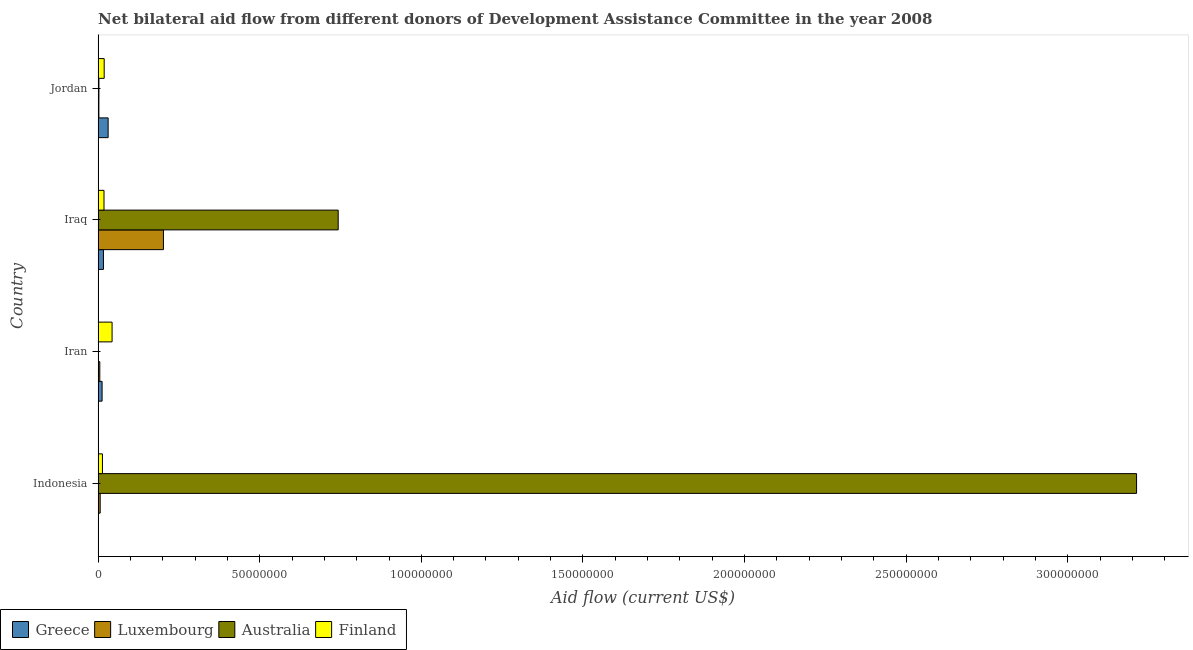Are the number of bars per tick equal to the number of legend labels?
Provide a succinct answer. Yes. Are the number of bars on each tick of the Y-axis equal?
Your answer should be compact. Yes. How many bars are there on the 4th tick from the bottom?
Your response must be concise. 4. What is the label of the 2nd group of bars from the top?
Provide a short and direct response. Iraq. In how many cases, is the number of bars for a given country not equal to the number of legend labels?
Your answer should be very brief. 0. What is the amount of aid given by luxembourg in Iran?
Ensure brevity in your answer.  5.20e+05. Across all countries, what is the maximum amount of aid given by greece?
Give a very brief answer. 3.10e+06. Across all countries, what is the minimum amount of aid given by luxembourg?
Your response must be concise. 2.40e+05. In which country was the amount of aid given by finland maximum?
Offer a very short reply. Iran. In which country was the amount of aid given by finland minimum?
Your response must be concise. Indonesia. What is the total amount of aid given by finland in the graph?
Offer a terse response. 9.36e+06. What is the difference between the amount of aid given by finland in Indonesia and that in Iran?
Provide a short and direct response. -2.98e+06. What is the difference between the amount of aid given by australia in Indonesia and the amount of aid given by luxembourg in Iraq?
Your answer should be compact. 3.01e+08. What is the average amount of aid given by luxembourg per country?
Your answer should be compact. 5.40e+06. What is the difference between the amount of aid given by australia and amount of aid given by greece in Jordan?
Your response must be concise. -2.85e+06. What is the ratio of the amount of aid given by australia in Iran to that in Jordan?
Your response must be concise. 0.12. Is the difference between the amount of aid given by luxembourg in Iraq and Jordan greater than the difference between the amount of aid given by greece in Iraq and Jordan?
Your answer should be very brief. Yes. What is the difference between the highest and the second highest amount of aid given by australia?
Provide a succinct answer. 2.47e+08. What is the difference between the highest and the lowest amount of aid given by australia?
Offer a terse response. 3.21e+08. In how many countries, is the amount of aid given by greece greater than the average amount of aid given by greece taken over all countries?
Ensure brevity in your answer.  2. What does the 3rd bar from the top in Indonesia represents?
Make the answer very short. Luxembourg. What does the 2nd bar from the bottom in Indonesia represents?
Keep it short and to the point. Luxembourg. How many bars are there?
Make the answer very short. 16. Are all the bars in the graph horizontal?
Provide a short and direct response. Yes. What is the difference between two consecutive major ticks on the X-axis?
Provide a short and direct response. 5.00e+07. Does the graph contain any zero values?
Make the answer very short. No. Does the graph contain grids?
Your response must be concise. No. How are the legend labels stacked?
Provide a short and direct response. Horizontal. What is the title of the graph?
Ensure brevity in your answer.  Net bilateral aid flow from different donors of Development Assistance Committee in the year 2008. Does "United Kingdom" appear as one of the legend labels in the graph?
Ensure brevity in your answer.  No. What is the label or title of the X-axis?
Keep it short and to the point. Aid flow (current US$). What is the label or title of the Y-axis?
Make the answer very short. Country. What is the Aid flow (current US$) in Greece in Indonesia?
Offer a terse response. 5.00e+04. What is the Aid flow (current US$) of Luxembourg in Indonesia?
Give a very brief answer. 6.40e+05. What is the Aid flow (current US$) of Australia in Indonesia?
Offer a very short reply. 3.21e+08. What is the Aid flow (current US$) in Finland in Indonesia?
Provide a succinct answer. 1.34e+06. What is the Aid flow (current US$) of Greece in Iran?
Your answer should be compact. 1.23e+06. What is the Aid flow (current US$) in Luxembourg in Iran?
Offer a very short reply. 5.20e+05. What is the Aid flow (current US$) of Finland in Iran?
Offer a terse response. 4.32e+06. What is the Aid flow (current US$) of Greece in Iraq?
Make the answer very short. 1.65e+06. What is the Aid flow (current US$) of Luxembourg in Iraq?
Provide a succinct answer. 2.02e+07. What is the Aid flow (current US$) of Australia in Iraq?
Give a very brief answer. 7.43e+07. What is the Aid flow (current US$) of Finland in Iraq?
Give a very brief answer. 1.82e+06. What is the Aid flow (current US$) of Greece in Jordan?
Offer a very short reply. 3.10e+06. What is the Aid flow (current US$) in Luxembourg in Jordan?
Your answer should be compact. 2.40e+05. What is the Aid flow (current US$) of Australia in Jordan?
Your answer should be very brief. 2.50e+05. What is the Aid flow (current US$) in Finland in Jordan?
Make the answer very short. 1.88e+06. Across all countries, what is the maximum Aid flow (current US$) in Greece?
Make the answer very short. 3.10e+06. Across all countries, what is the maximum Aid flow (current US$) in Luxembourg?
Provide a succinct answer. 2.02e+07. Across all countries, what is the maximum Aid flow (current US$) in Australia?
Offer a very short reply. 3.21e+08. Across all countries, what is the maximum Aid flow (current US$) in Finland?
Ensure brevity in your answer.  4.32e+06. Across all countries, what is the minimum Aid flow (current US$) in Greece?
Make the answer very short. 5.00e+04. Across all countries, what is the minimum Aid flow (current US$) of Finland?
Offer a very short reply. 1.34e+06. What is the total Aid flow (current US$) in Greece in the graph?
Give a very brief answer. 6.03e+06. What is the total Aid flow (current US$) of Luxembourg in the graph?
Your answer should be very brief. 2.16e+07. What is the total Aid flow (current US$) of Australia in the graph?
Your response must be concise. 3.96e+08. What is the total Aid flow (current US$) of Finland in the graph?
Offer a very short reply. 9.36e+06. What is the difference between the Aid flow (current US$) of Greece in Indonesia and that in Iran?
Your answer should be compact. -1.18e+06. What is the difference between the Aid flow (current US$) in Luxembourg in Indonesia and that in Iran?
Keep it short and to the point. 1.20e+05. What is the difference between the Aid flow (current US$) of Australia in Indonesia and that in Iran?
Your answer should be compact. 3.21e+08. What is the difference between the Aid flow (current US$) in Finland in Indonesia and that in Iran?
Your response must be concise. -2.98e+06. What is the difference between the Aid flow (current US$) in Greece in Indonesia and that in Iraq?
Offer a very short reply. -1.60e+06. What is the difference between the Aid flow (current US$) of Luxembourg in Indonesia and that in Iraq?
Your answer should be very brief. -1.96e+07. What is the difference between the Aid flow (current US$) in Australia in Indonesia and that in Iraq?
Offer a very short reply. 2.47e+08. What is the difference between the Aid flow (current US$) of Finland in Indonesia and that in Iraq?
Keep it short and to the point. -4.80e+05. What is the difference between the Aid flow (current US$) of Greece in Indonesia and that in Jordan?
Your answer should be compact. -3.05e+06. What is the difference between the Aid flow (current US$) in Luxembourg in Indonesia and that in Jordan?
Ensure brevity in your answer.  4.00e+05. What is the difference between the Aid flow (current US$) of Australia in Indonesia and that in Jordan?
Offer a terse response. 3.21e+08. What is the difference between the Aid flow (current US$) of Finland in Indonesia and that in Jordan?
Make the answer very short. -5.40e+05. What is the difference between the Aid flow (current US$) of Greece in Iran and that in Iraq?
Ensure brevity in your answer.  -4.20e+05. What is the difference between the Aid flow (current US$) in Luxembourg in Iran and that in Iraq?
Your response must be concise. -1.97e+07. What is the difference between the Aid flow (current US$) in Australia in Iran and that in Iraq?
Ensure brevity in your answer.  -7.42e+07. What is the difference between the Aid flow (current US$) of Finland in Iran and that in Iraq?
Make the answer very short. 2.50e+06. What is the difference between the Aid flow (current US$) of Greece in Iran and that in Jordan?
Give a very brief answer. -1.87e+06. What is the difference between the Aid flow (current US$) in Luxembourg in Iran and that in Jordan?
Offer a very short reply. 2.80e+05. What is the difference between the Aid flow (current US$) of Australia in Iran and that in Jordan?
Ensure brevity in your answer.  -2.20e+05. What is the difference between the Aid flow (current US$) in Finland in Iran and that in Jordan?
Ensure brevity in your answer.  2.44e+06. What is the difference between the Aid flow (current US$) in Greece in Iraq and that in Jordan?
Your answer should be very brief. -1.45e+06. What is the difference between the Aid flow (current US$) in Luxembourg in Iraq and that in Jordan?
Offer a terse response. 2.00e+07. What is the difference between the Aid flow (current US$) in Australia in Iraq and that in Jordan?
Make the answer very short. 7.40e+07. What is the difference between the Aid flow (current US$) in Greece in Indonesia and the Aid flow (current US$) in Luxembourg in Iran?
Keep it short and to the point. -4.70e+05. What is the difference between the Aid flow (current US$) in Greece in Indonesia and the Aid flow (current US$) in Finland in Iran?
Provide a short and direct response. -4.27e+06. What is the difference between the Aid flow (current US$) in Luxembourg in Indonesia and the Aid flow (current US$) in Australia in Iran?
Your response must be concise. 6.10e+05. What is the difference between the Aid flow (current US$) of Luxembourg in Indonesia and the Aid flow (current US$) of Finland in Iran?
Offer a very short reply. -3.68e+06. What is the difference between the Aid flow (current US$) in Australia in Indonesia and the Aid flow (current US$) in Finland in Iran?
Provide a succinct answer. 3.17e+08. What is the difference between the Aid flow (current US$) in Greece in Indonesia and the Aid flow (current US$) in Luxembourg in Iraq?
Make the answer very short. -2.02e+07. What is the difference between the Aid flow (current US$) of Greece in Indonesia and the Aid flow (current US$) of Australia in Iraq?
Ensure brevity in your answer.  -7.42e+07. What is the difference between the Aid flow (current US$) in Greece in Indonesia and the Aid flow (current US$) in Finland in Iraq?
Make the answer very short. -1.77e+06. What is the difference between the Aid flow (current US$) of Luxembourg in Indonesia and the Aid flow (current US$) of Australia in Iraq?
Provide a short and direct response. -7.36e+07. What is the difference between the Aid flow (current US$) in Luxembourg in Indonesia and the Aid flow (current US$) in Finland in Iraq?
Your answer should be compact. -1.18e+06. What is the difference between the Aid flow (current US$) of Australia in Indonesia and the Aid flow (current US$) of Finland in Iraq?
Ensure brevity in your answer.  3.19e+08. What is the difference between the Aid flow (current US$) of Greece in Indonesia and the Aid flow (current US$) of Luxembourg in Jordan?
Make the answer very short. -1.90e+05. What is the difference between the Aid flow (current US$) of Greece in Indonesia and the Aid flow (current US$) of Australia in Jordan?
Your response must be concise. -2.00e+05. What is the difference between the Aid flow (current US$) of Greece in Indonesia and the Aid flow (current US$) of Finland in Jordan?
Ensure brevity in your answer.  -1.83e+06. What is the difference between the Aid flow (current US$) of Luxembourg in Indonesia and the Aid flow (current US$) of Finland in Jordan?
Offer a terse response. -1.24e+06. What is the difference between the Aid flow (current US$) of Australia in Indonesia and the Aid flow (current US$) of Finland in Jordan?
Offer a terse response. 3.19e+08. What is the difference between the Aid flow (current US$) in Greece in Iran and the Aid flow (current US$) in Luxembourg in Iraq?
Give a very brief answer. -1.90e+07. What is the difference between the Aid flow (current US$) of Greece in Iran and the Aid flow (current US$) of Australia in Iraq?
Provide a succinct answer. -7.30e+07. What is the difference between the Aid flow (current US$) of Greece in Iran and the Aid flow (current US$) of Finland in Iraq?
Keep it short and to the point. -5.90e+05. What is the difference between the Aid flow (current US$) of Luxembourg in Iran and the Aid flow (current US$) of Australia in Iraq?
Make the answer very short. -7.38e+07. What is the difference between the Aid flow (current US$) of Luxembourg in Iran and the Aid flow (current US$) of Finland in Iraq?
Your answer should be very brief. -1.30e+06. What is the difference between the Aid flow (current US$) of Australia in Iran and the Aid flow (current US$) of Finland in Iraq?
Make the answer very short. -1.79e+06. What is the difference between the Aid flow (current US$) of Greece in Iran and the Aid flow (current US$) of Luxembourg in Jordan?
Offer a terse response. 9.90e+05. What is the difference between the Aid flow (current US$) of Greece in Iran and the Aid flow (current US$) of Australia in Jordan?
Offer a very short reply. 9.80e+05. What is the difference between the Aid flow (current US$) of Greece in Iran and the Aid flow (current US$) of Finland in Jordan?
Give a very brief answer. -6.50e+05. What is the difference between the Aid flow (current US$) of Luxembourg in Iran and the Aid flow (current US$) of Finland in Jordan?
Ensure brevity in your answer.  -1.36e+06. What is the difference between the Aid flow (current US$) of Australia in Iran and the Aid flow (current US$) of Finland in Jordan?
Give a very brief answer. -1.85e+06. What is the difference between the Aid flow (current US$) in Greece in Iraq and the Aid flow (current US$) in Luxembourg in Jordan?
Offer a very short reply. 1.41e+06. What is the difference between the Aid flow (current US$) of Greece in Iraq and the Aid flow (current US$) of Australia in Jordan?
Give a very brief answer. 1.40e+06. What is the difference between the Aid flow (current US$) of Luxembourg in Iraq and the Aid flow (current US$) of Australia in Jordan?
Keep it short and to the point. 2.00e+07. What is the difference between the Aid flow (current US$) in Luxembourg in Iraq and the Aid flow (current US$) in Finland in Jordan?
Make the answer very short. 1.83e+07. What is the difference between the Aid flow (current US$) of Australia in Iraq and the Aid flow (current US$) of Finland in Jordan?
Offer a very short reply. 7.24e+07. What is the average Aid flow (current US$) in Greece per country?
Your response must be concise. 1.51e+06. What is the average Aid flow (current US$) of Luxembourg per country?
Keep it short and to the point. 5.40e+06. What is the average Aid flow (current US$) of Australia per country?
Offer a terse response. 9.90e+07. What is the average Aid flow (current US$) in Finland per country?
Your answer should be very brief. 2.34e+06. What is the difference between the Aid flow (current US$) in Greece and Aid flow (current US$) in Luxembourg in Indonesia?
Offer a terse response. -5.90e+05. What is the difference between the Aid flow (current US$) of Greece and Aid flow (current US$) of Australia in Indonesia?
Your answer should be compact. -3.21e+08. What is the difference between the Aid flow (current US$) of Greece and Aid flow (current US$) of Finland in Indonesia?
Your response must be concise. -1.29e+06. What is the difference between the Aid flow (current US$) of Luxembourg and Aid flow (current US$) of Australia in Indonesia?
Provide a succinct answer. -3.21e+08. What is the difference between the Aid flow (current US$) of Luxembourg and Aid flow (current US$) of Finland in Indonesia?
Provide a succinct answer. -7.00e+05. What is the difference between the Aid flow (current US$) in Australia and Aid flow (current US$) in Finland in Indonesia?
Your response must be concise. 3.20e+08. What is the difference between the Aid flow (current US$) in Greece and Aid flow (current US$) in Luxembourg in Iran?
Give a very brief answer. 7.10e+05. What is the difference between the Aid flow (current US$) in Greece and Aid flow (current US$) in Australia in Iran?
Give a very brief answer. 1.20e+06. What is the difference between the Aid flow (current US$) in Greece and Aid flow (current US$) in Finland in Iran?
Keep it short and to the point. -3.09e+06. What is the difference between the Aid flow (current US$) in Luxembourg and Aid flow (current US$) in Australia in Iran?
Provide a short and direct response. 4.90e+05. What is the difference between the Aid flow (current US$) in Luxembourg and Aid flow (current US$) in Finland in Iran?
Offer a very short reply. -3.80e+06. What is the difference between the Aid flow (current US$) of Australia and Aid flow (current US$) of Finland in Iran?
Offer a very short reply. -4.29e+06. What is the difference between the Aid flow (current US$) of Greece and Aid flow (current US$) of Luxembourg in Iraq?
Make the answer very short. -1.86e+07. What is the difference between the Aid flow (current US$) in Greece and Aid flow (current US$) in Australia in Iraq?
Offer a very short reply. -7.26e+07. What is the difference between the Aid flow (current US$) in Luxembourg and Aid flow (current US$) in Australia in Iraq?
Provide a short and direct response. -5.41e+07. What is the difference between the Aid flow (current US$) of Luxembourg and Aid flow (current US$) of Finland in Iraq?
Your answer should be compact. 1.84e+07. What is the difference between the Aid flow (current US$) of Australia and Aid flow (current US$) of Finland in Iraq?
Provide a succinct answer. 7.25e+07. What is the difference between the Aid flow (current US$) in Greece and Aid flow (current US$) in Luxembourg in Jordan?
Provide a succinct answer. 2.86e+06. What is the difference between the Aid flow (current US$) of Greece and Aid flow (current US$) of Australia in Jordan?
Make the answer very short. 2.85e+06. What is the difference between the Aid flow (current US$) of Greece and Aid flow (current US$) of Finland in Jordan?
Offer a very short reply. 1.22e+06. What is the difference between the Aid flow (current US$) in Luxembourg and Aid flow (current US$) in Finland in Jordan?
Provide a succinct answer. -1.64e+06. What is the difference between the Aid flow (current US$) in Australia and Aid flow (current US$) in Finland in Jordan?
Your answer should be very brief. -1.63e+06. What is the ratio of the Aid flow (current US$) of Greece in Indonesia to that in Iran?
Your answer should be very brief. 0.04. What is the ratio of the Aid flow (current US$) in Luxembourg in Indonesia to that in Iran?
Offer a terse response. 1.23. What is the ratio of the Aid flow (current US$) in Australia in Indonesia to that in Iran?
Give a very brief answer. 1.07e+04. What is the ratio of the Aid flow (current US$) of Finland in Indonesia to that in Iran?
Provide a short and direct response. 0.31. What is the ratio of the Aid flow (current US$) of Greece in Indonesia to that in Iraq?
Provide a succinct answer. 0.03. What is the ratio of the Aid flow (current US$) of Luxembourg in Indonesia to that in Iraq?
Provide a short and direct response. 0.03. What is the ratio of the Aid flow (current US$) in Australia in Indonesia to that in Iraq?
Your answer should be compact. 4.33. What is the ratio of the Aid flow (current US$) of Finland in Indonesia to that in Iraq?
Your answer should be very brief. 0.74. What is the ratio of the Aid flow (current US$) in Greece in Indonesia to that in Jordan?
Provide a short and direct response. 0.02. What is the ratio of the Aid flow (current US$) in Luxembourg in Indonesia to that in Jordan?
Your answer should be very brief. 2.67. What is the ratio of the Aid flow (current US$) in Australia in Indonesia to that in Jordan?
Make the answer very short. 1285.2. What is the ratio of the Aid flow (current US$) in Finland in Indonesia to that in Jordan?
Provide a short and direct response. 0.71. What is the ratio of the Aid flow (current US$) in Greece in Iran to that in Iraq?
Offer a very short reply. 0.75. What is the ratio of the Aid flow (current US$) of Luxembourg in Iran to that in Iraq?
Offer a terse response. 0.03. What is the ratio of the Aid flow (current US$) of Finland in Iran to that in Iraq?
Your answer should be very brief. 2.37. What is the ratio of the Aid flow (current US$) in Greece in Iran to that in Jordan?
Give a very brief answer. 0.4. What is the ratio of the Aid flow (current US$) of Luxembourg in Iran to that in Jordan?
Ensure brevity in your answer.  2.17. What is the ratio of the Aid flow (current US$) of Australia in Iran to that in Jordan?
Give a very brief answer. 0.12. What is the ratio of the Aid flow (current US$) in Finland in Iran to that in Jordan?
Your answer should be compact. 2.3. What is the ratio of the Aid flow (current US$) of Greece in Iraq to that in Jordan?
Give a very brief answer. 0.53. What is the ratio of the Aid flow (current US$) in Luxembourg in Iraq to that in Jordan?
Make the answer very short. 84.21. What is the ratio of the Aid flow (current US$) in Australia in Iraq to that in Jordan?
Your answer should be very brief. 297.12. What is the ratio of the Aid flow (current US$) of Finland in Iraq to that in Jordan?
Make the answer very short. 0.97. What is the difference between the highest and the second highest Aid flow (current US$) of Greece?
Your answer should be very brief. 1.45e+06. What is the difference between the highest and the second highest Aid flow (current US$) of Luxembourg?
Offer a terse response. 1.96e+07. What is the difference between the highest and the second highest Aid flow (current US$) of Australia?
Give a very brief answer. 2.47e+08. What is the difference between the highest and the second highest Aid flow (current US$) of Finland?
Give a very brief answer. 2.44e+06. What is the difference between the highest and the lowest Aid flow (current US$) in Greece?
Offer a terse response. 3.05e+06. What is the difference between the highest and the lowest Aid flow (current US$) in Luxembourg?
Ensure brevity in your answer.  2.00e+07. What is the difference between the highest and the lowest Aid flow (current US$) in Australia?
Your response must be concise. 3.21e+08. What is the difference between the highest and the lowest Aid flow (current US$) in Finland?
Your answer should be compact. 2.98e+06. 